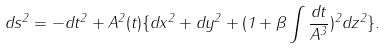Convert formula to latex. <formula><loc_0><loc_0><loc_500><loc_500>d s ^ { 2 } = - d t ^ { 2 } + A ^ { 2 } ( t ) \{ d x ^ { 2 } + d y ^ { 2 } + ( 1 + \beta \int \frac { d t } { A ^ { 3 } } ) ^ { 2 } d z ^ { 2 } \} .</formula> 